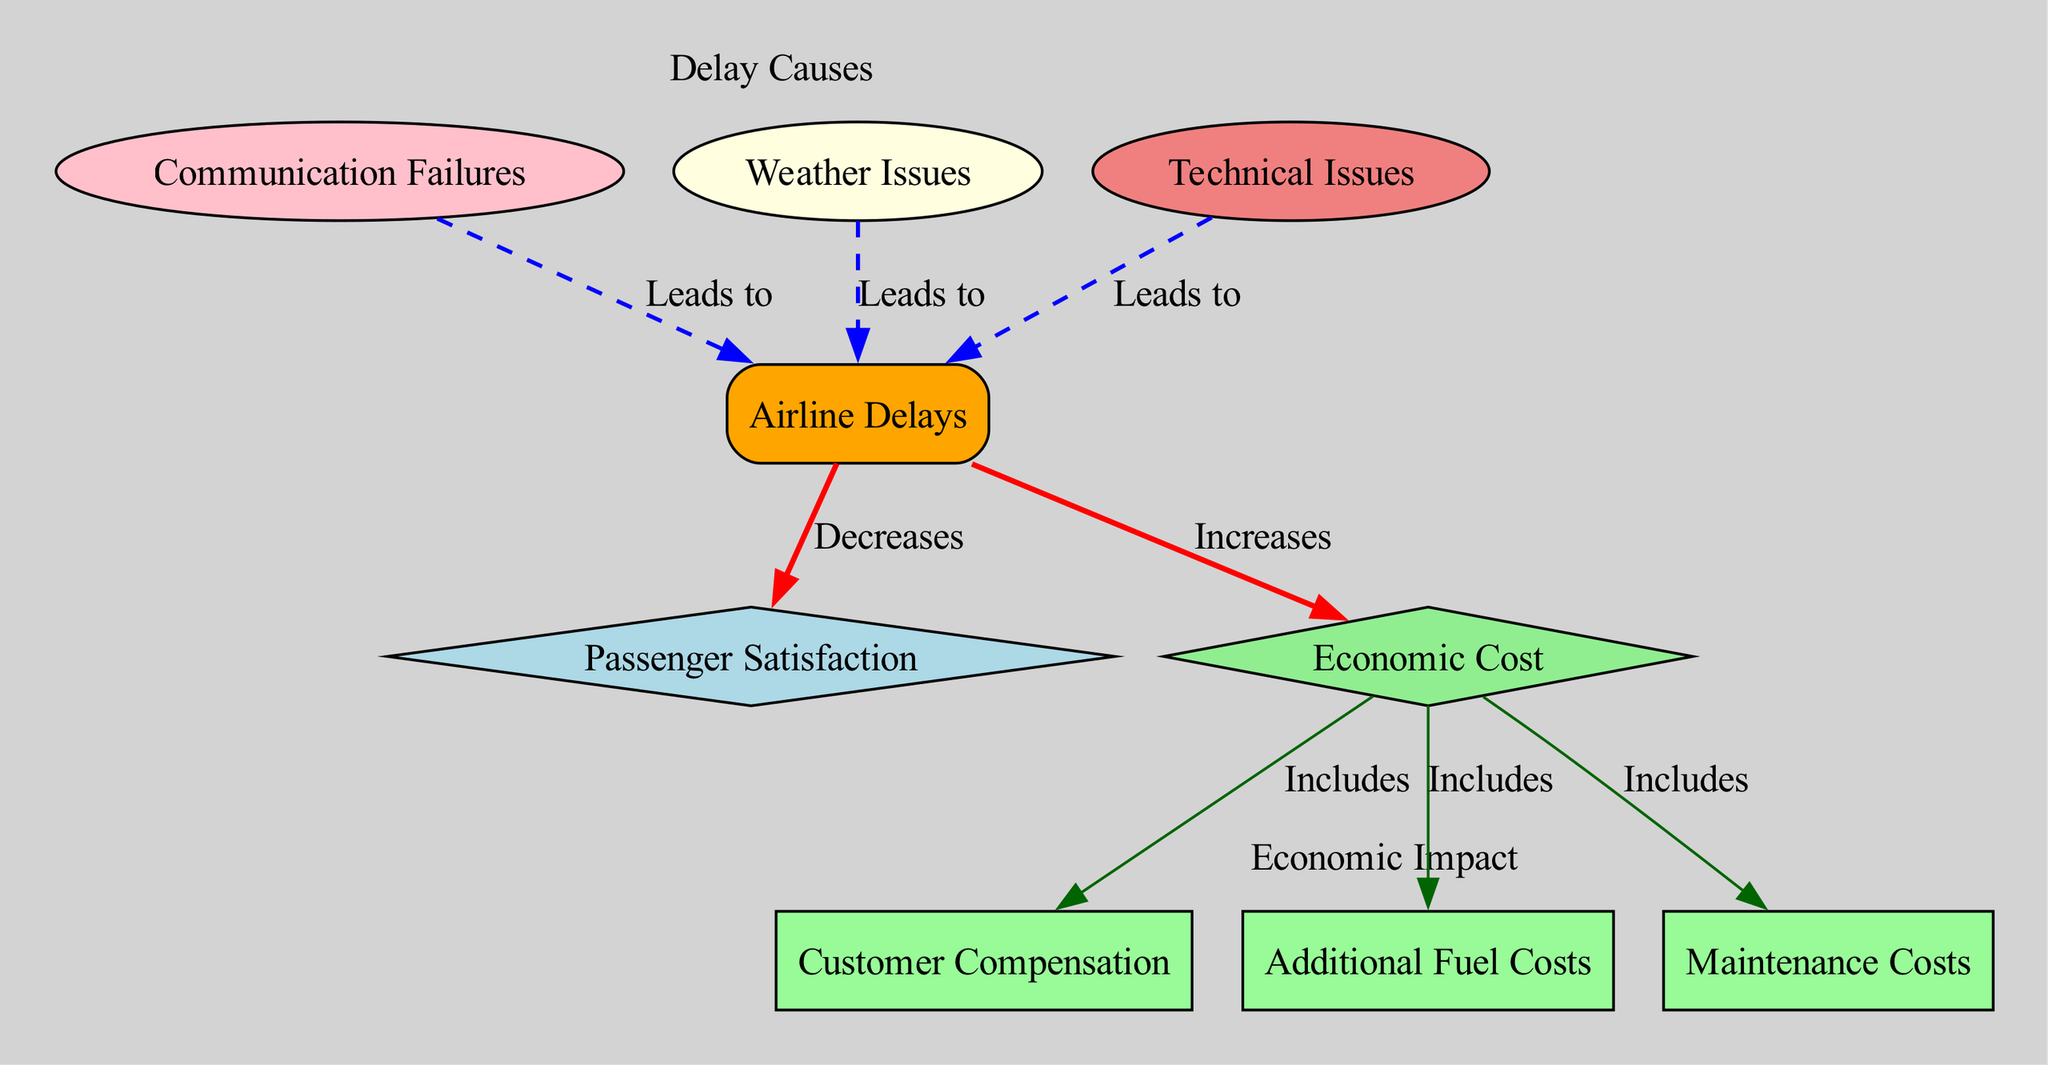What is the relationship between airline delays and passenger satisfaction? Airline delays decrease passenger satisfaction, as indicated by the labeled edge connecting these two nodes in the diagram.
Answer: Decreases How many causes for airline delays are represented in the diagram? The diagram shows three causes for airline delays: communication failures, weather issues, and technical issues. These are listed as distinct nodes feeding into the airline delays node.
Answer: 3 What types of costs are included in the economic cost node? The economic cost node includes three specific costs: customer compensation, additional fuel costs, and maintenance costs, as shown in the edges leading from the economic cost node to these three nodes.
Answer: Customer compensation, additional fuel costs, maintenance costs Which cause of airline delays is represented in the same category as communication failures? Weather issues and technical issues are both shown as causes of airline delays and are included in the same subgraph labeled "Delay Causes."
Answer: Weather issues What effect do airline delays have on economic cost? Airline delays increase economic cost, as shown by the directed edge connecting airline delays to economic cost with the label "Increases."
Answer: Increases Which node is affected by all three causes of airline delays? The airline delays node is affected by communication failures, weather issues, and technical issues, as indicated by the edges leading to it from each of these causes.
Answer: Airline delays What color represents the economic cost node? The economic cost node is colored light green, as specified in the node styles section of the diagram generation code.
Answer: Light green What is the visual shape of the passenger satisfaction node? The passenger satisfaction node is depicted in the shape of a diamond, as specified in the node styles for that particular node.
Answer: Diamond What do communication failures lead to? Communication failures lead to airline delays, as indicated by the directed edge connecting these two nodes with the label "Leads to."
Answer: Airline delays 